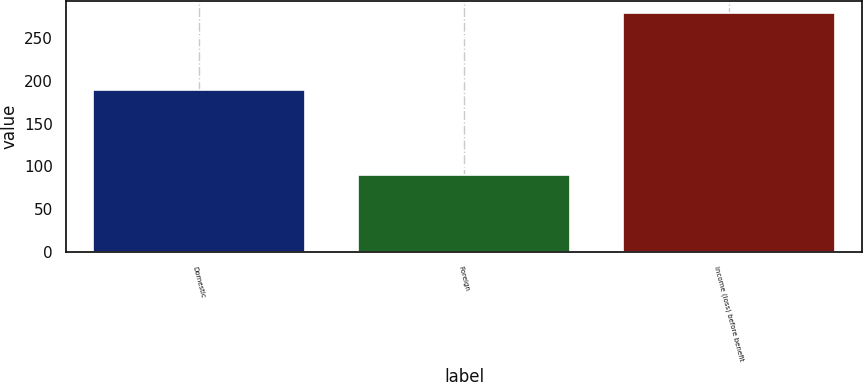<chart> <loc_0><loc_0><loc_500><loc_500><bar_chart><fcel>Domestic<fcel>Foreign<fcel>Income (loss) before benefit<nl><fcel>189<fcel>90<fcel>279<nl></chart> 